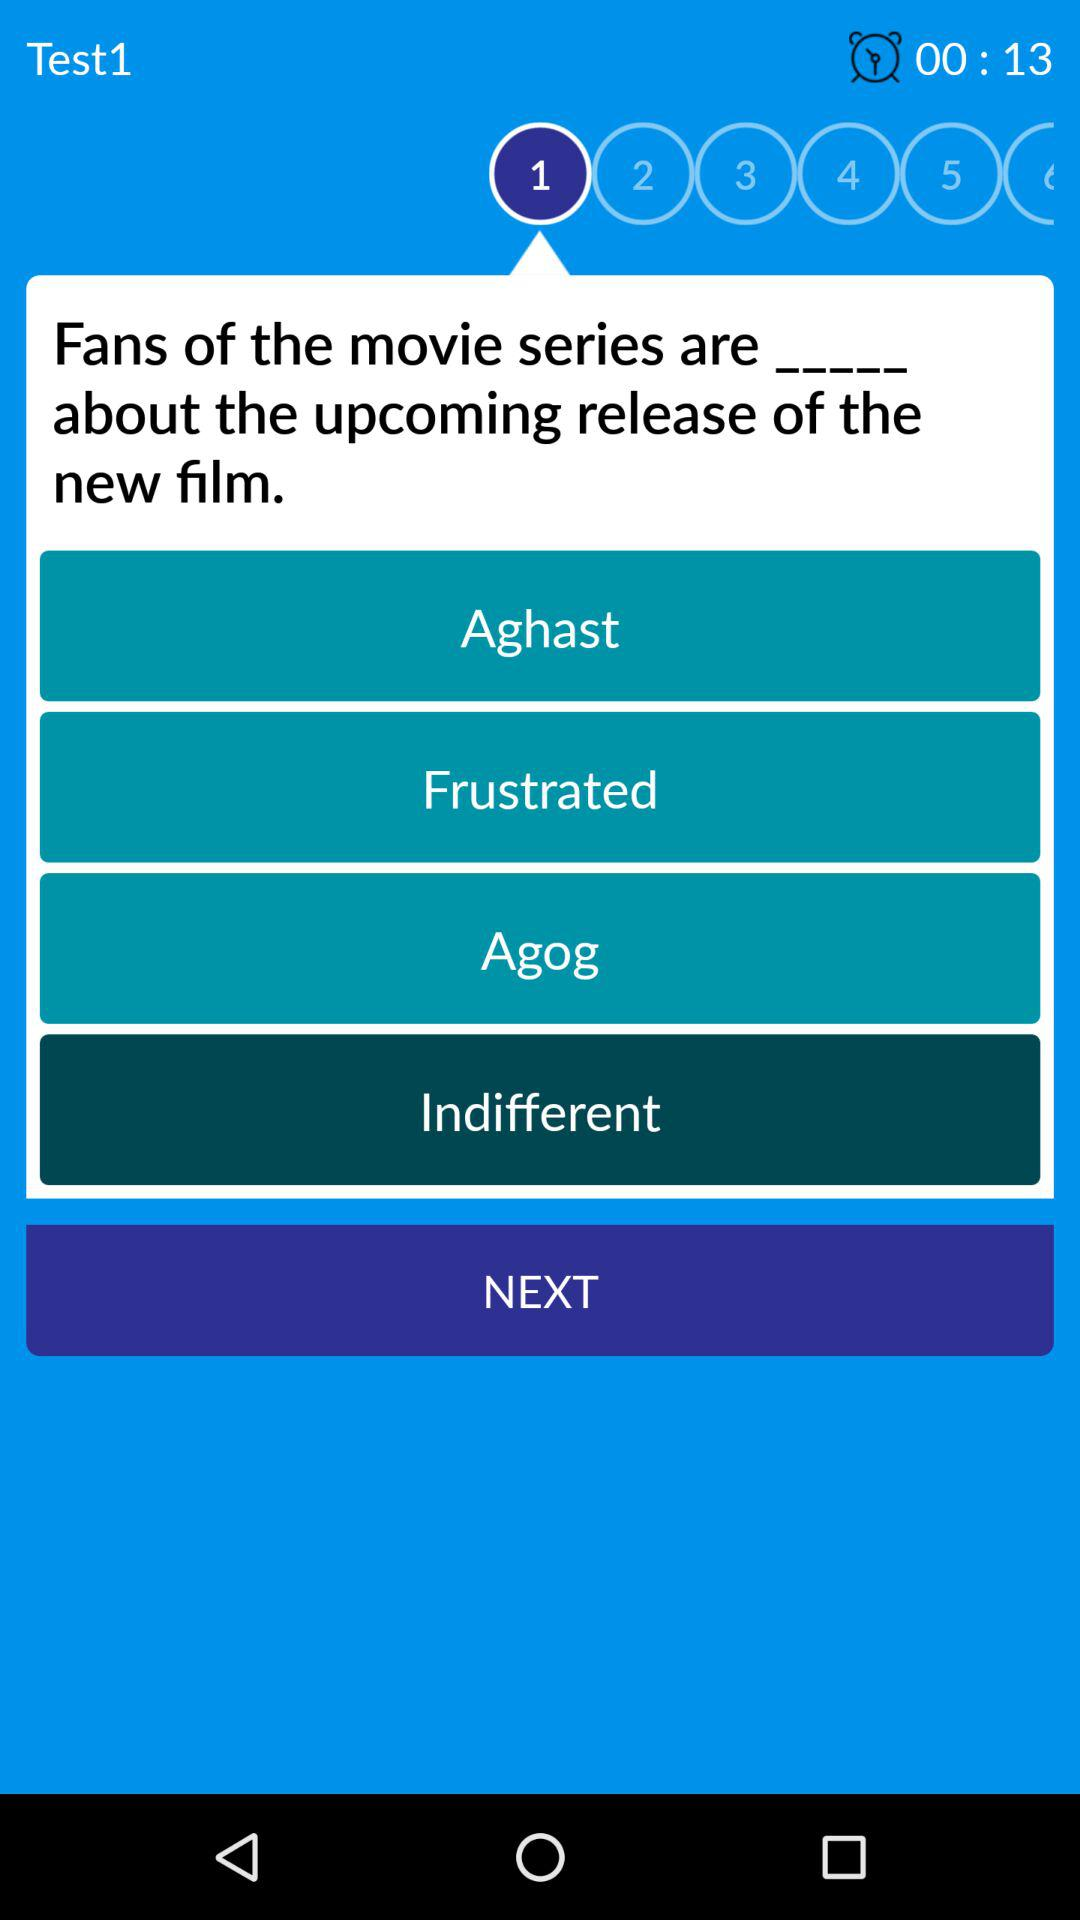What time is left for the question? The left time is 13 seconds. 